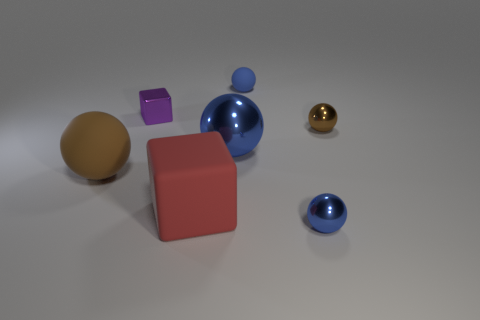How many blue balls must be subtracted to get 1 blue balls? 2 Subtract all large rubber spheres. How many spheres are left? 4 Subtract all blue balls. How many balls are left? 2 Add 1 brown rubber objects. How many objects exist? 8 Subtract all balls. How many objects are left? 2 Subtract all brown balls. How many red blocks are left? 1 Subtract all tiny blue rubber things. Subtract all purple objects. How many objects are left? 5 Add 7 small blue matte spheres. How many small blue matte spheres are left? 8 Add 2 purple cubes. How many purple cubes exist? 3 Subtract 1 brown spheres. How many objects are left? 6 